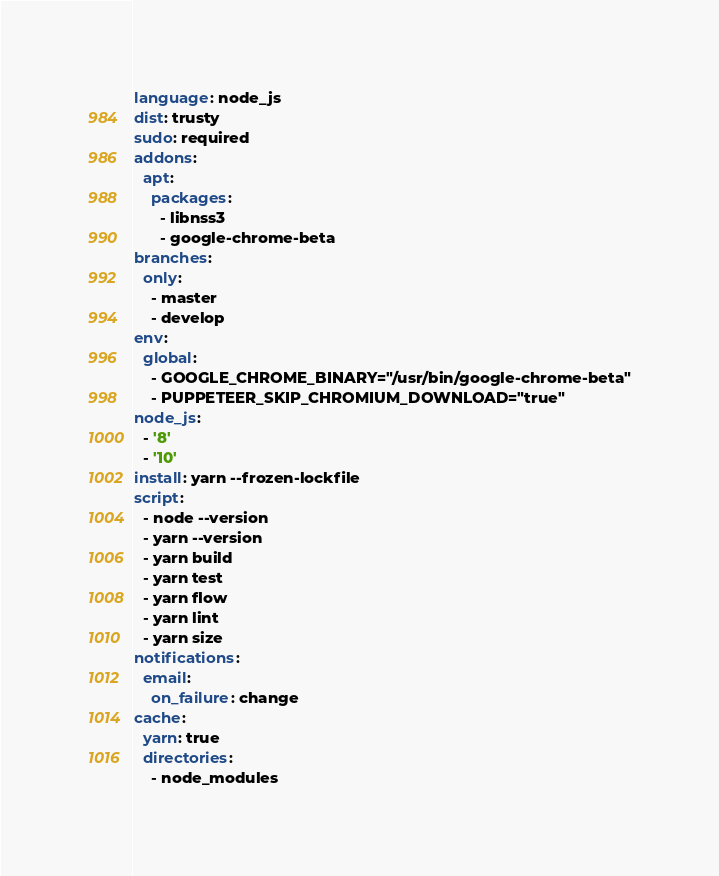<code> <loc_0><loc_0><loc_500><loc_500><_YAML_>language: node_js
dist: trusty
sudo: required
addons:
  apt:
    packages:
      - libnss3
      - google-chrome-beta
branches:
  only:
    - master
    - develop
env:
  global:
    - GOOGLE_CHROME_BINARY="/usr/bin/google-chrome-beta"
    - PUPPETEER_SKIP_CHROMIUM_DOWNLOAD="true"
node_js:
  - '8'
  - '10'
install: yarn --frozen-lockfile
script:
  - node --version
  - yarn --version
  - yarn build
  - yarn test
  - yarn flow
  - yarn lint
  - yarn size
notifications:
  email:
    on_failure: change
cache:
  yarn: true
  directories:
    - node_modules
</code> 